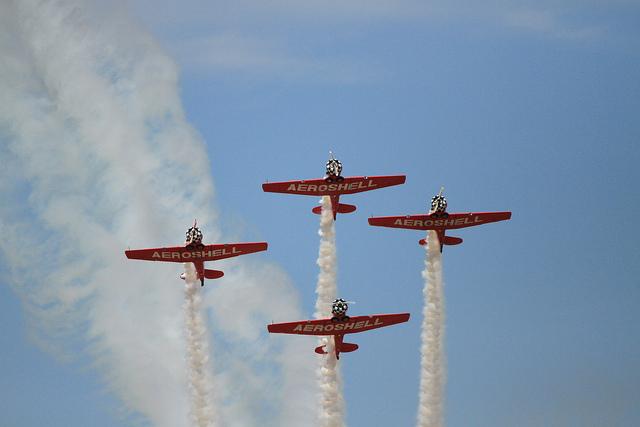Are these planes flying in formation?
Give a very brief answer. Yes. Do these planes do tricks?
Keep it brief. Yes. What word is on the underside of the wings?
Concise answer only. Aeroshell. 